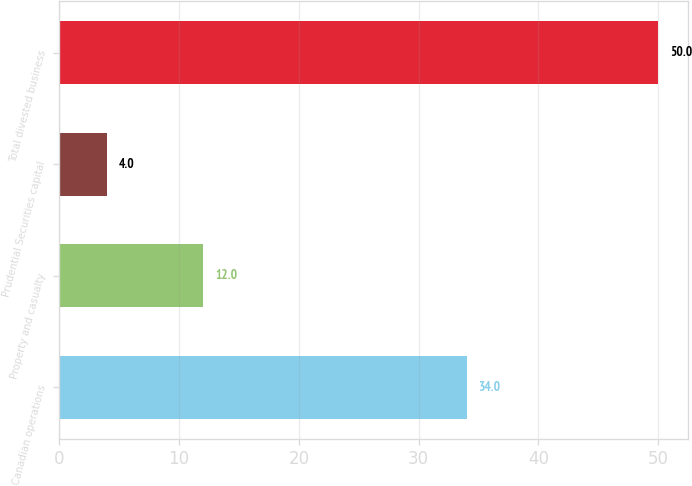Convert chart. <chart><loc_0><loc_0><loc_500><loc_500><bar_chart><fcel>Canadian operations<fcel>Property and casualty<fcel>Prudential Securities capital<fcel>Total divested business<nl><fcel>34<fcel>12<fcel>4<fcel>50<nl></chart> 